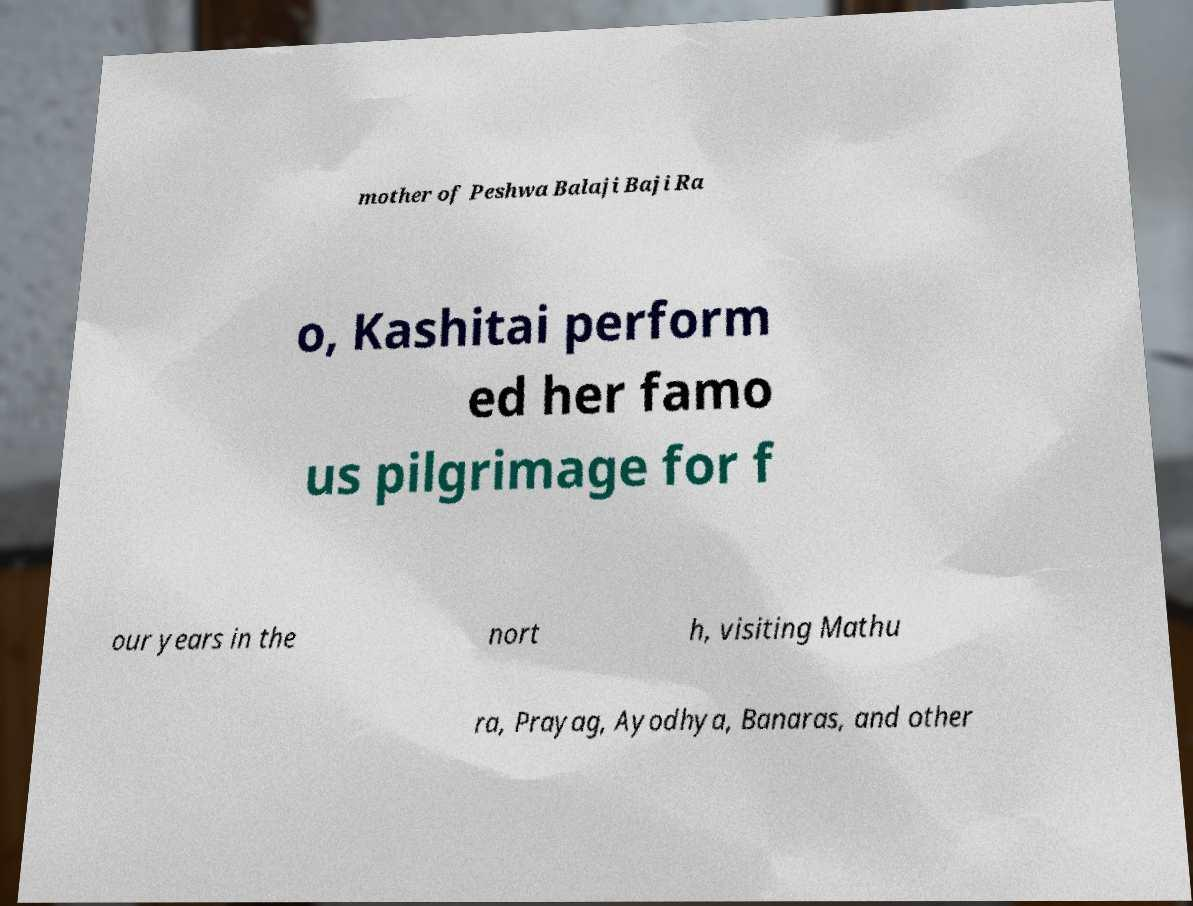Can you accurately transcribe the text from the provided image for me? mother of Peshwa Balaji Baji Ra o, Kashitai perform ed her famo us pilgrimage for f our years in the nort h, visiting Mathu ra, Prayag, Ayodhya, Banaras, and other 